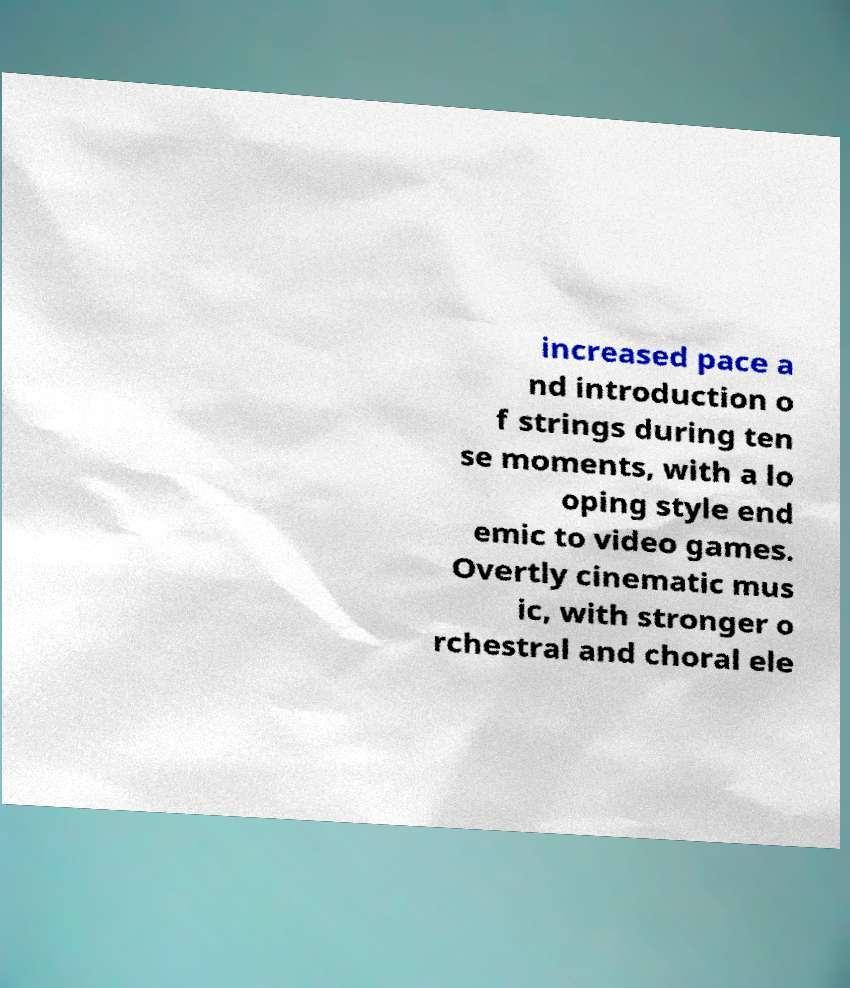Could you assist in decoding the text presented in this image and type it out clearly? increased pace a nd introduction o f strings during ten se moments, with a lo oping style end emic to video games. Overtly cinematic mus ic, with stronger o rchestral and choral ele 